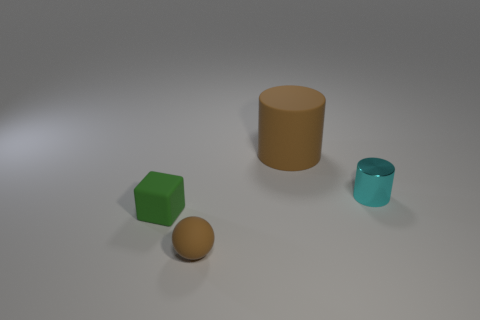Are there any other things that are the same size as the matte cylinder?
Make the answer very short. No. Is the number of matte objects right of the tiny brown ball greater than the number of yellow objects?
Your response must be concise. Yes. How many things are either yellow shiny balls or brown matte cylinders?
Your answer should be very brief. 1. The large rubber thing has what color?
Keep it short and to the point. Brown. How many other objects are there of the same color as the ball?
Your response must be concise. 1. Are there any rubber cylinders right of the ball?
Ensure brevity in your answer.  Yes. The small thing right of the small rubber thing right of the tiny matte thing that is behind the small rubber ball is what color?
Offer a very short reply. Cyan. What number of tiny objects are both to the left of the small brown matte sphere and on the right side of the large thing?
Ensure brevity in your answer.  0. What number of balls are either brown matte things or large matte things?
Provide a succinct answer. 1. Are any big purple balls visible?
Keep it short and to the point. No. 